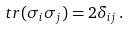<formula> <loc_0><loc_0><loc_500><loc_500>\ t r ( \sigma _ { i } \sigma _ { j } ) = 2 \delta _ { i j } \, .</formula> 